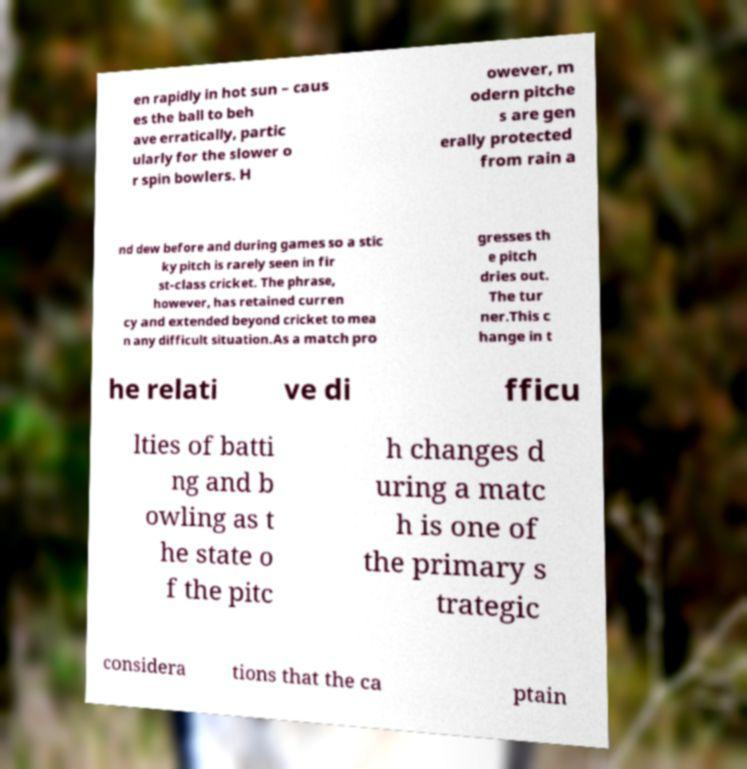Can you read and provide the text displayed in the image?This photo seems to have some interesting text. Can you extract and type it out for me? en rapidly in hot sun – caus es the ball to beh ave erratically, partic ularly for the slower o r spin bowlers. H owever, m odern pitche s are gen erally protected from rain a nd dew before and during games so a stic ky pitch is rarely seen in fir st-class cricket. The phrase, however, has retained curren cy and extended beyond cricket to mea n any difficult situation.As a match pro gresses th e pitch dries out. The tur ner.This c hange in t he relati ve di fficu lties of batti ng and b owling as t he state o f the pitc h changes d uring a matc h is one of the primary s trategic considera tions that the ca ptain 